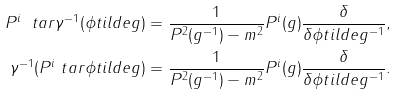Convert formula to latex. <formula><loc_0><loc_0><loc_500><loc_500>P ^ { i } \ t a r \gamma ^ { - 1 } ( \phi t i l d e { g } ) & = \frac { 1 } { P ^ { 2 } ( g ^ { - 1 } ) - m ^ { 2 } } P ^ { i } ( g ) \frac { \delta } { \delta \phi t i l d e { g ^ { - 1 } } } , \\ \gamma ^ { - 1 } ( P ^ { i } \ t a r \phi t i l d e { g } ) & = \frac { 1 } { P ^ { 2 } ( g ^ { - 1 } ) - m ^ { 2 } } P ^ { i } ( g ) \frac { \delta } { \delta \phi t i l d e { g ^ { - 1 } } } .</formula> 